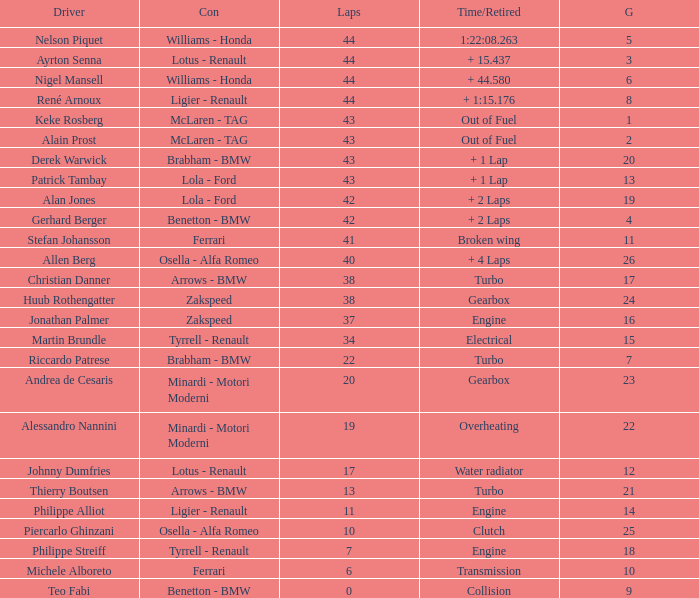I want the driver that has Laps of 10 Piercarlo Ghinzani. 